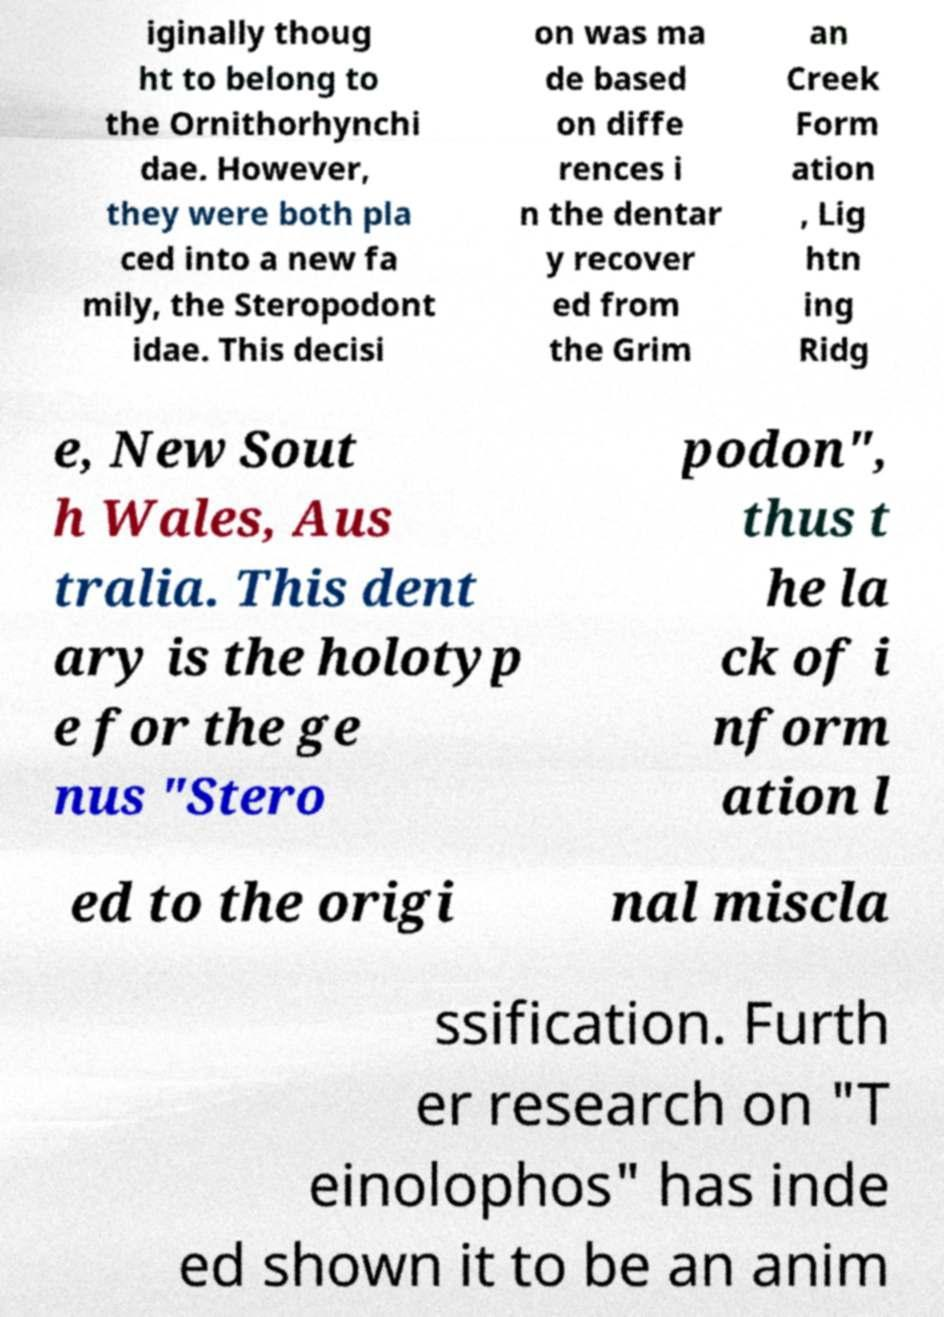For documentation purposes, I need the text within this image transcribed. Could you provide that? iginally thoug ht to belong to the Ornithorhynchi dae. However, they were both pla ced into a new fa mily, the Steropodont idae. This decisi on was ma de based on diffe rences i n the dentar y recover ed from the Grim an Creek Form ation , Lig htn ing Ridg e, New Sout h Wales, Aus tralia. This dent ary is the holotyp e for the ge nus "Stero podon", thus t he la ck of i nform ation l ed to the origi nal miscla ssification. Furth er research on "T einolophos" has inde ed shown it to be an anim 